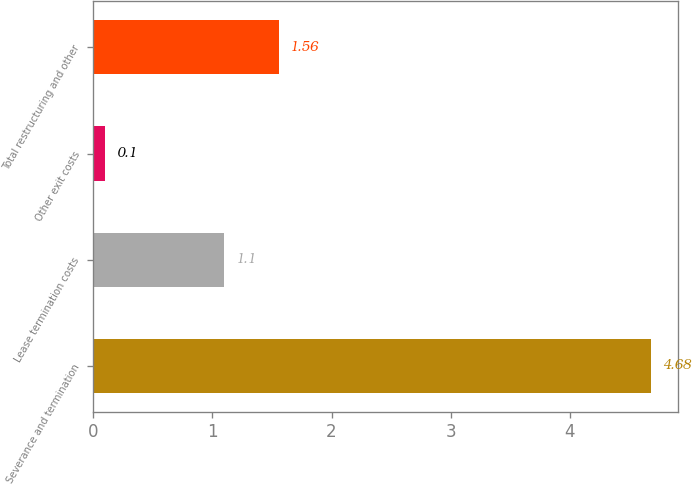<chart> <loc_0><loc_0><loc_500><loc_500><bar_chart><fcel>Severance and termination<fcel>Lease termination costs<fcel>Other exit costs<fcel>Total restructuring and other<nl><fcel>4.68<fcel>1.1<fcel>0.1<fcel>1.56<nl></chart> 